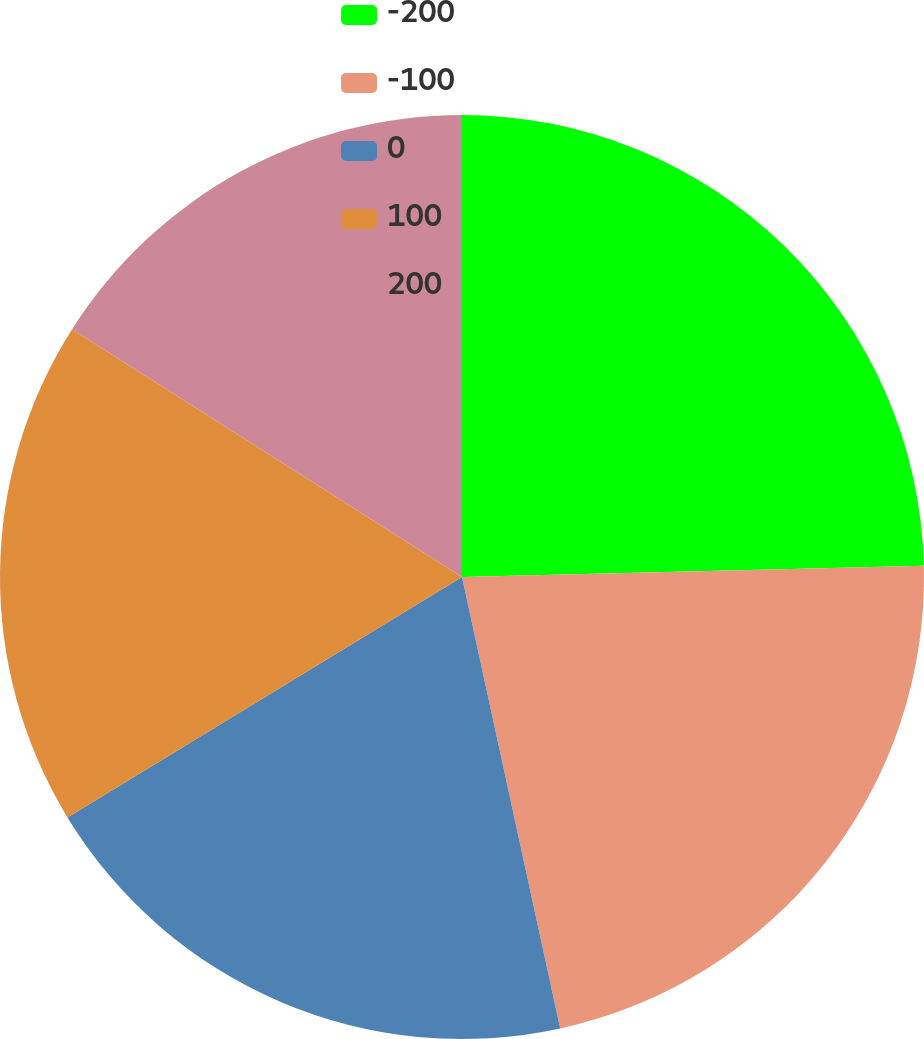Convert chart to OTSL. <chart><loc_0><loc_0><loc_500><loc_500><pie_chart><fcel>-200<fcel>-100<fcel>0<fcel>100<fcel>200<nl><fcel>24.61%<fcel>21.98%<fcel>19.7%<fcel>17.72%<fcel>15.99%<nl></chart> 